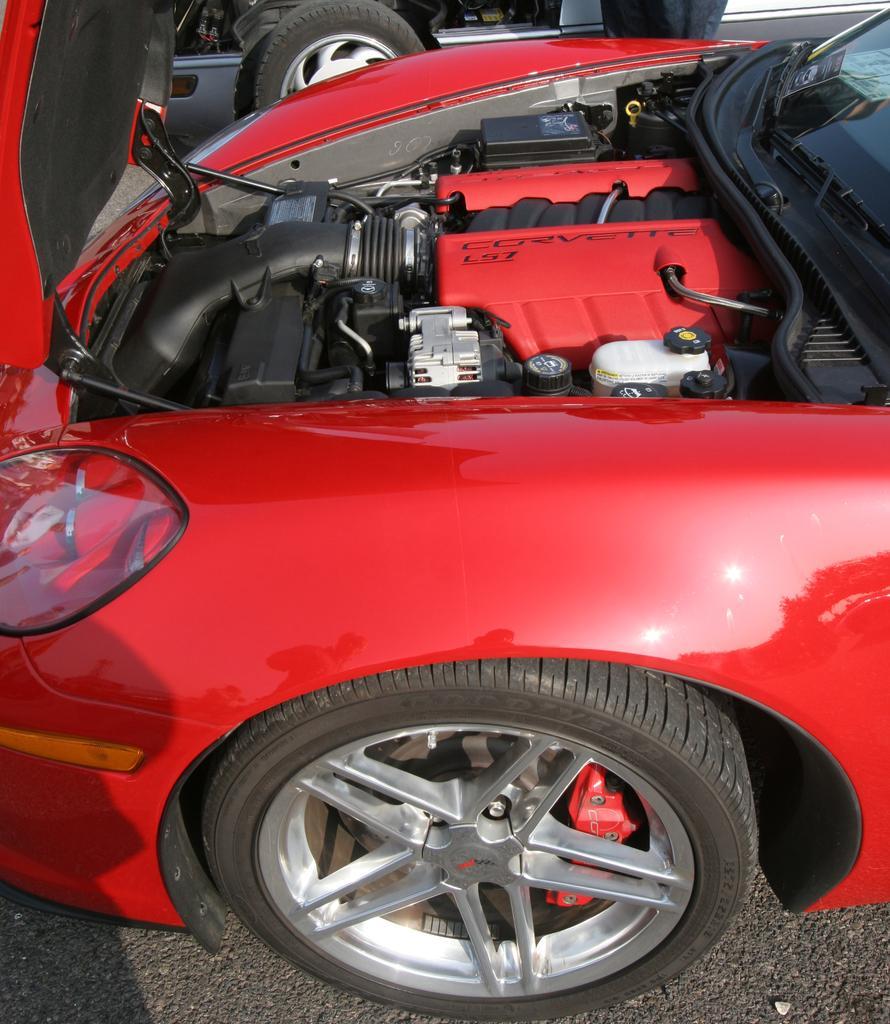Describe this image in one or two sentences. In this image we can see motor vehicles on the road. 